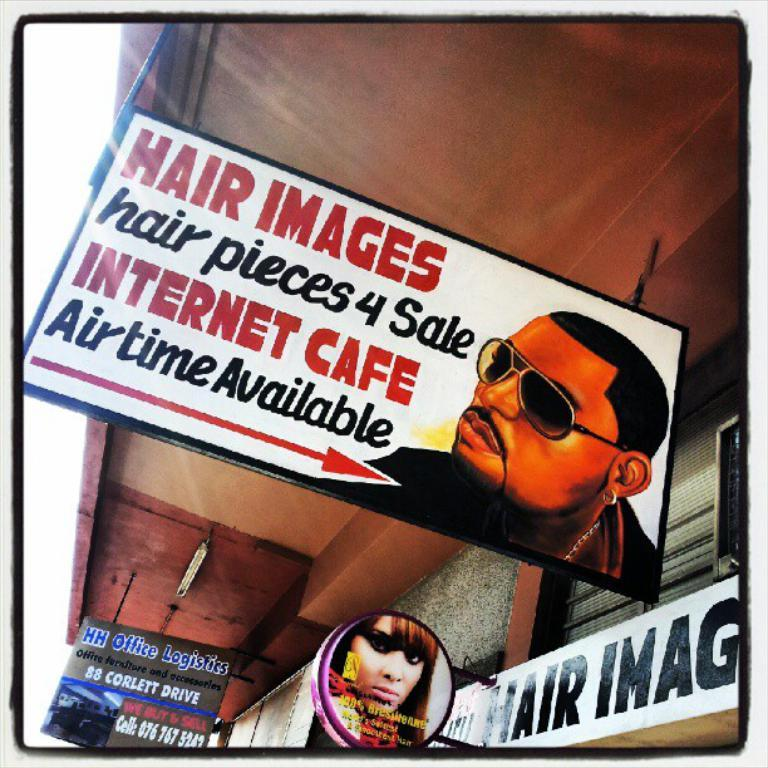What is the main subject of the image? The main subject of the image is advertisements. What else can be seen in the image besides the advertisements? There are name boards, persons, and walls visible in the image. How many frogs are present in the image? There are no frogs present in the image. What type of badge can be seen on the persons in the image? There is no badge visible on the persons in the image. 